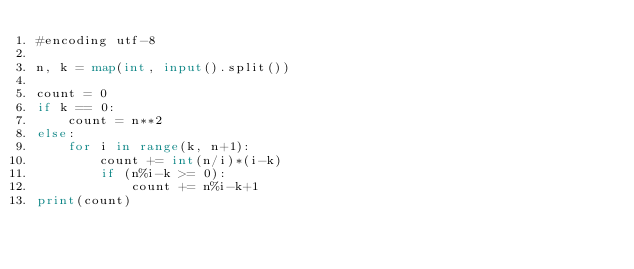Convert code to text. <code><loc_0><loc_0><loc_500><loc_500><_Python_>#encoding utf-8

n, k = map(int, input().split())

count = 0
if k == 0:
    count = n**2
else:
    for i in range(k, n+1):
        count += int(n/i)*(i-k)
        if (n%i-k >= 0):
            count += n%i-k+1
print(count)
</code> 